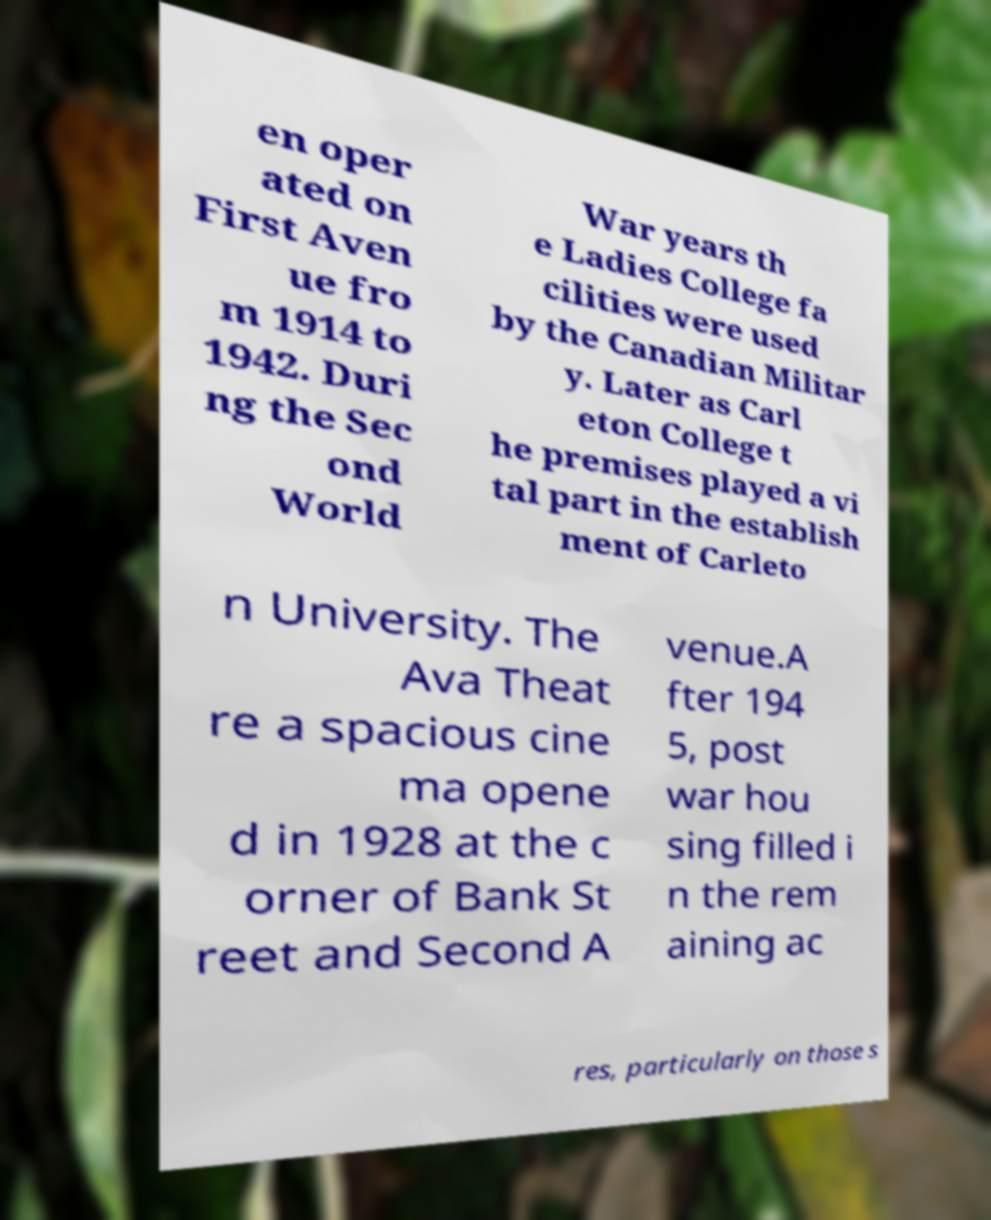Could you assist in decoding the text presented in this image and type it out clearly? en oper ated on First Aven ue fro m 1914 to 1942. Duri ng the Sec ond World War years th e Ladies College fa cilities were used by the Canadian Militar y. Later as Carl eton College t he premises played a vi tal part in the establish ment of Carleto n University. The Ava Theat re a spacious cine ma opene d in 1928 at the c orner of Bank St reet and Second A venue.A fter 194 5, post war hou sing filled i n the rem aining ac res, particularly on those s 